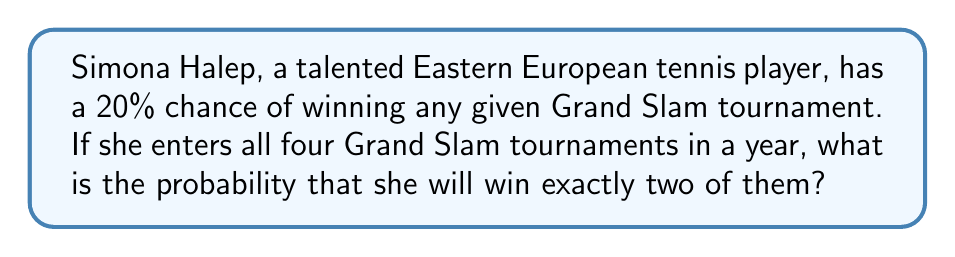Could you help me with this problem? To solve this problem, we'll use the binomial probability formula, as we're dealing with a fixed number of independent trials (4 Grand Slam tournaments) with two possible outcomes for each (win or not win).

1. Let's define our variables:
   $n = 4$ (number of trials/tournaments)
   $k = 2$ (number of successes/wins we're interested in)
   $p = 0.20$ (probability of success in each trial)
   $q = 1 - p = 0.80$ (probability of failure in each trial)

2. The binomial probability formula is:

   $$P(X = k) = \binom{n}{k} p^k q^{n-k}$$

3. We need to calculate $\binom{n}{k}$, which is the number of ways to choose $k$ items from $n$ items:

   $$\binom{4}{2} = \frac{4!}{2!(4-2)!} = \frac{4 \cdot 3}{2 \cdot 1} = 6$$

4. Now, let's substitute all values into the formula:

   $$P(X = 2) = 6 \cdot (0.20)^2 \cdot (0.80)^{4-2}$$

5. Simplify:
   $$P(X = 2) = 6 \cdot 0.04 \cdot 0.64 = 0.1536$$

6. Convert to a percentage:
   $$0.1536 \cdot 100\% = 15.36\%$$
Answer: 15.36% 